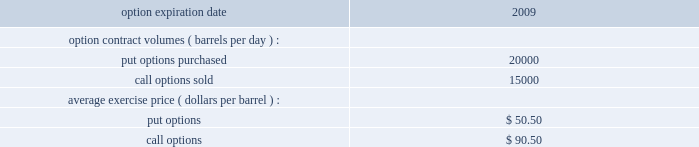Underlying physical transaction occurs .
We have not qualified commodity derivative instruments used in our osm or rm&t segments for hedge accounting .
As a result , we recognize in net income all changes in the fair value of derivative instruments used in those operations .
Open commodity derivative positions as of december 31 , 2008 and sensitivity analysis at december 31 , 2008 , our e&p segment held open derivative contracts to mitigate the price risk on natural gas held in storage or purchased to be marketed with our own natural gas production in amounts that were in line with normal levels of activity .
At december 31 , 2008 , we had no significant open derivative contracts related to our future sales of liquid hydrocarbons and natural gas and therefore remained substantially exposed to market prices of these commodities .
The osm segment holds crude oil options which were purchased by western for a three year period ( january 2007 to december 2009 ) .
The premiums for the purchased put options had been partially offset through the sale of call options for the same three-year period , resulting in a net premium liability .
Payment of the net premium liability is deferred until the settlement of the option contracts .
As of december 31 , 2008 , the following put and call options were outstanding: .
In the first quarter of 2009 , we sold derivative instruments at an average exercise price of $ 50.50 which effectively offset the open put options for the remainder of 2009 .
At december 31 , 2008 , the number of open derivative contracts held by our rm&t segment was lower than in previous periods .
Starting in the second quarter of 2008 , we decreased our use of derivatives to mitigate crude oil price risk between the time that domestic spot crude oil purchases are priced and when they are actually refined into salable petroleum products .
Instead , we are addressing this price risk through other means , including changes in contractual terms and crude oil acquisition practices .
Additionally , in previous periods , certain contracts in our rm&t segment for the purchase or sale of commodities were not qualified or designated as normal purchase or normal sales under generally accepted accounting principles and therefore were accounted for as derivative instruments .
During the second quarter of 2008 , as we decreased our use of derivatives , we began to designate such contracts for the normal purchase and normal sale exclusion. .
Was the average exercise price ( dollars per barrel ) of put options expiring in 2009 greater than that of call options? 
Computations: (50.50 > 90.50)
Answer: no. Underlying physical transaction occurs .
We have not qualified commodity derivative instruments used in our osm or rm&t segments for hedge accounting .
As a result , we recognize in net income all changes in the fair value of derivative instruments used in those operations .
Open commodity derivative positions as of december 31 , 2008 and sensitivity analysis at december 31 , 2008 , our e&p segment held open derivative contracts to mitigate the price risk on natural gas held in storage or purchased to be marketed with our own natural gas production in amounts that were in line with normal levels of activity .
At december 31 , 2008 , we had no significant open derivative contracts related to our future sales of liquid hydrocarbons and natural gas and therefore remained substantially exposed to market prices of these commodities .
The osm segment holds crude oil options which were purchased by western for a three year period ( january 2007 to december 2009 ) .
The premiums for the purchased put options had been partially offset through the sale of call options for the same three-year period , resulting in a net premium liability .
Payment of the net premium liability is deferred until the settlement of the option contracts .
As of december 31 , 2008 , the following put and call options were outstanding: .
In the first quarter of 2009 , we sold derivative instruments at an average exercise price of $ 50.50 which effectively offset the open put options for the remainder of 2009 .
At december 31 , 2008 , the number of open derivative contracts held by our rm&t segment was lower than in previous periods .
Starting in the second quarter of 2008 , we decreased our use of derivatives to mitigate crude oil price risk between the time that domestic spot crude oil purchases are priced and when they are actually refined into salable petroleum products .
Instead , we are addressing this price risk through other means , including changes in contractual terms and crude oil acquisition practices .
Additionally , in previous periods , certain contracts in our rm&t segment for the purchase or sale of commodities were not qualified or designated as normal purchase or normal sales under generally accepted accounting principles and therefore were accounted for as derivative instruments .
During the second quarter of 2008 , as we decreased our use of derivatives , we began to designate such contracts for the normal purchase and normal sale exclusion. .
Using the above listed average exercise price , what were the value of the call options sold? 
Computations: (15000 * 90.50)
Answer: 1357500.0. Underlying physical transaction occurs .
We have not qualified commodity derivative instruments used in our osm or rm&t segments for hedge accounting .
As a result , we recognize in net income all changes in the fair value of derivative instruments used in those operations .
Open commodity derivative positions as of december 31 , 2008 and sensitivity analysis at december 31 , 2008 , our e&p segment held open derivative contracts to mitigate the price risk on natural gas held in storage or purchased to be marketed with our own natural gas production in amounts that were in line with normal levels of activity .
At december 31 , 2008 , we had no significant open derivative contracts related to our future sales of liquid hydrocarbons and natural gas and therefore remained substantially exposed to market prices of these commodities .
The osm segment holds crude oil options which were purchased by western for a three year period ( january 2007 to december 2009 ) .
The premiums for the purchased put options had been partially offset through the sale of call options for the same three-year period , resulting in a net premium liability .
Payment of the net premium liability is deferred until the settlement of the option contracts .
As of december 31 , 2008 , the following put and call options were outstanding: .
In the first quarter of 2009 , we sold derivative instruments at an average exercise price of $ 50.50 which effectively offset the open put options for the remainder of 2009 .
At december 31 , 2008 , the number of open derivative contracts held by our rm&t segment was lower than in previous periods .
Starting in the second quarter of 2008 , we decreased our use of derivatives to mitigate crude oil price risk between the time that domestic spot crude oil purchases are priced and when they are actually refined into salable petroleum products .
Instead , we are addressing this price risk through other means , including changes in contractual terms and crude oil acquisition practices .
Additionally , in previous periods , certain contracts in our rm&t segment for the purchase or sale of commodities were not qualified or designated as normal purchase or normal sales under generally accepted accounting principles and therefore were accounted for as derivative instruments .
During the second quarter of 2008 , as we decreased our use of derivatives , we began to designate such contracts for the normal purchase and normal sale exclusion. .
For option expiration dates in 2009 , what was the average option contract volumes ( barrels per day ) for put options purchased and \\ncall options sold? 
Computations: ((20000 + 15000) / 2)
Answer: 17500.0. 